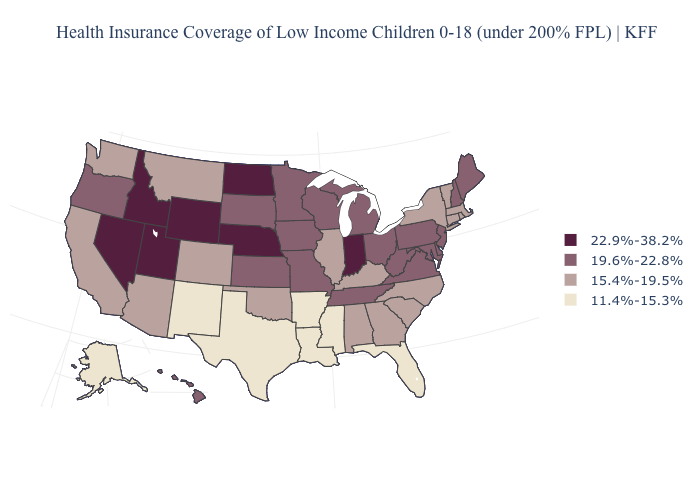What is the highest value in the Northeast ?
Give a very brief answer. 19.6%-22.8%. Among the states that border New Jersey , does Delaware have the highest value?
Write a very short answer. Yes. What is the lowest value in the USA?
Give a very brief answer. 11.4%-15.3%. Does Pennsylvania have the lowest value in the USA?
Be succinct. No. Name the states that have a value in the range 22.9%-38.2%?
Short answer required. Idaho, Indiana, Nebraska, Nevada, North Dakota, Utah, Wyoming. Does the map have missing data?
Concise answer only. No. Among the states that border Washington , does Idaho have the lowest value?
Concise answer only. No. Among the states that border Mississippi , which have the lowest value?
Keep it brief. Arkansas, Louisiana. Which states have the lowest value in the USA?
Write a very short answer. Alaska, Arkansas, Florida, Louisiana, Mississippi, New Mexico, Texas. Does Virginia have the lowest value in the USA?
Quick response, please. No. What is the lowest value in states that border Connecticut?
Short answer required. 15.4%-19.5%. What is the value of Hawaii?
Quick response, please. 19.6%-22.8%. Which states hav the highest value in the MidWest?
Write a very short answer. Indiana, Nebraska, North Dakota. What is the highest value in states that border New York?
Be succinct. 19.6%-22.8%. Name the states that have a value in the range 19.6%-22.8%?
Quick response, please. Delaware, Hawaii, Iowa, Kansas, Maine, Maryland, Michigan, Minnesota, Missouri, New Hampshire, New Jersey, Ohio, Oregon, Pennsylvania, South Dakota, Tennessee, Virginia, West Virginia, Wisconsin. 